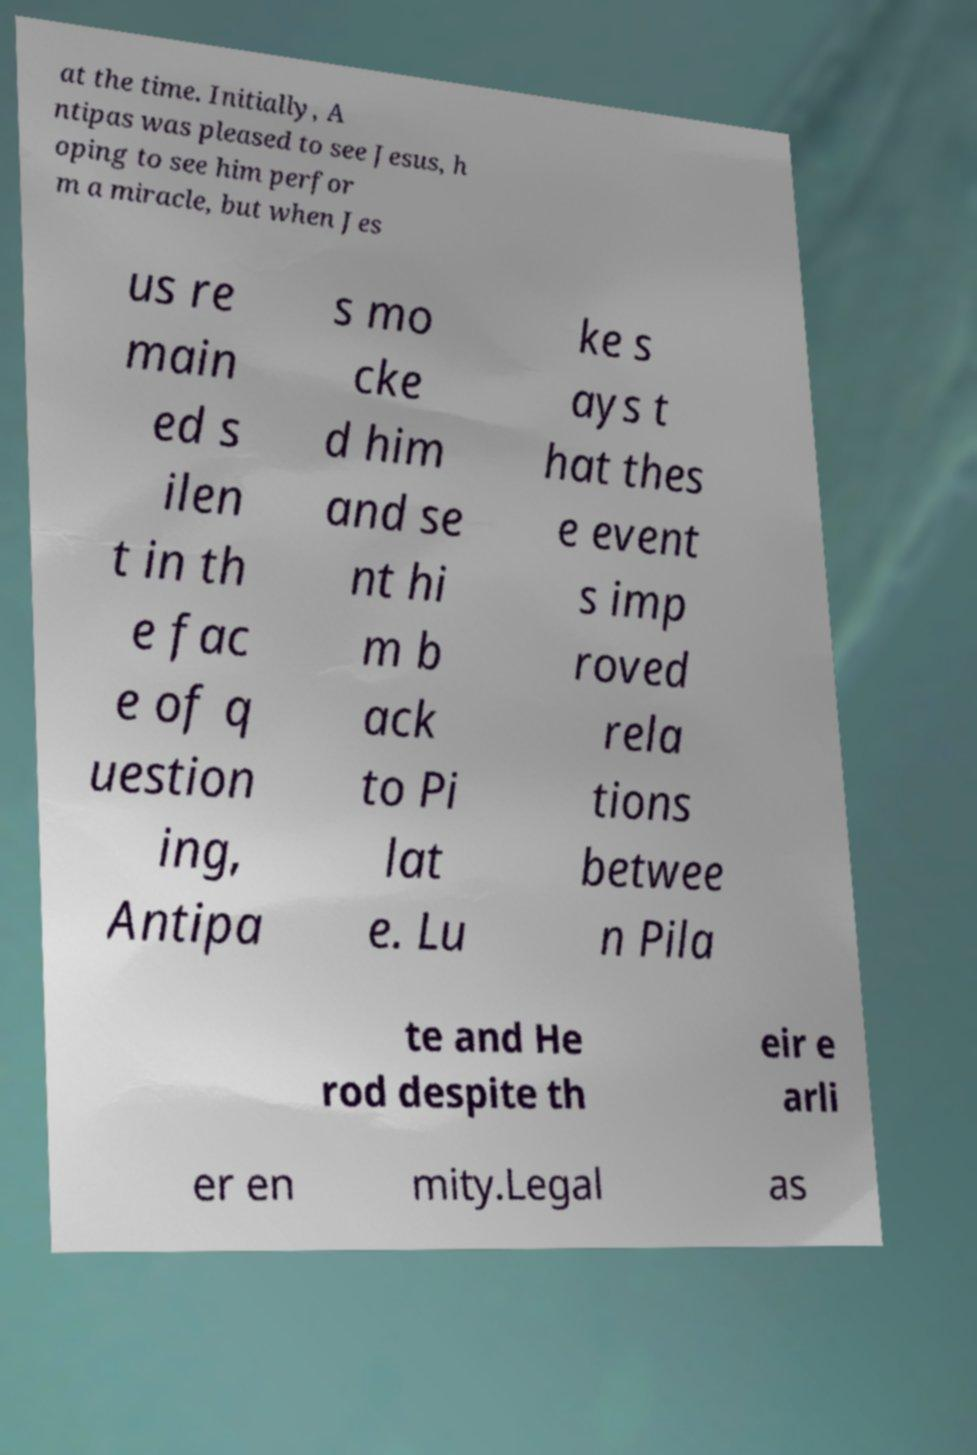Please identify and transcribe the text found in this image. at the time. Initially, A ntipas was pleased to see Jesus, h oping to see him perfor m a miracle, but when Jes us re main ed s ilen t in th e fac e of q uestion ing, Antipa s mo cke d him and se nt hi m b ack to Pi lat e. Lu ke s ays t hat thes e event s imp roved rela tions betwee n Pila te and He rod despite th eir e arli er en mity.Legal as 